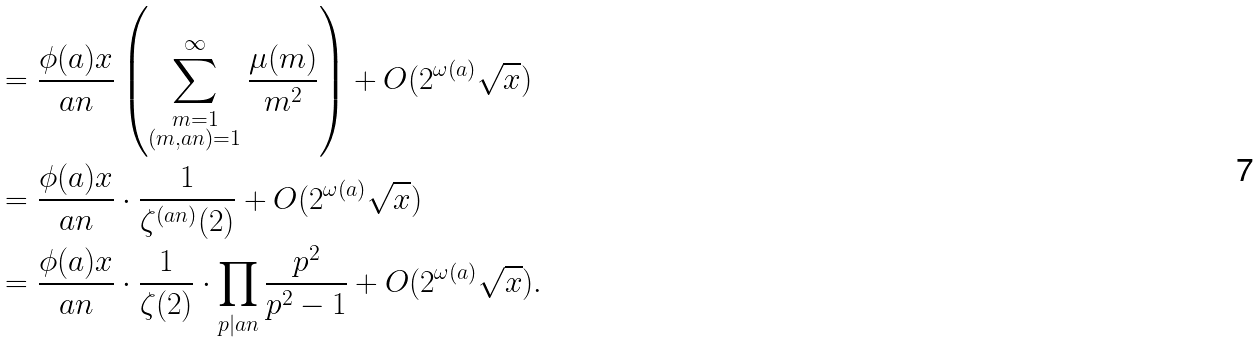<formula> <loc_0><loc_0><loc_500><loc_500>& = \frac { \phi ( a ) x } { a n } \left ( \sum ^ { \infty } _ { \substack { m = 1 \\ ( m , a n ) = 1 } } \frac { \mu ( m ) } { m ^ { 2 } } \right ) + O ( 2 ^ { \omega ( a ) } \sqrt { x } ) \\ & = \frac { \phi ( a ) x } { a n } \cdot \frac { 1 } { \zeta ^ { ( a n ) } ( 2 ) } + O ( 2 ^ { \omega ( a ) } \sqrt { x } ) \\ & = \frac { \phi ( a ) x } { a n } \cdot \frac { 1 } { \zeta ( 2 ) } \cdot \prod _ { p | a n } \frac { p ^ { 2 } } { p ^ { 2 } - 1 } + O ( 2 ^ { \omega ( a ) } \sqrt { x } ) .</formula> 